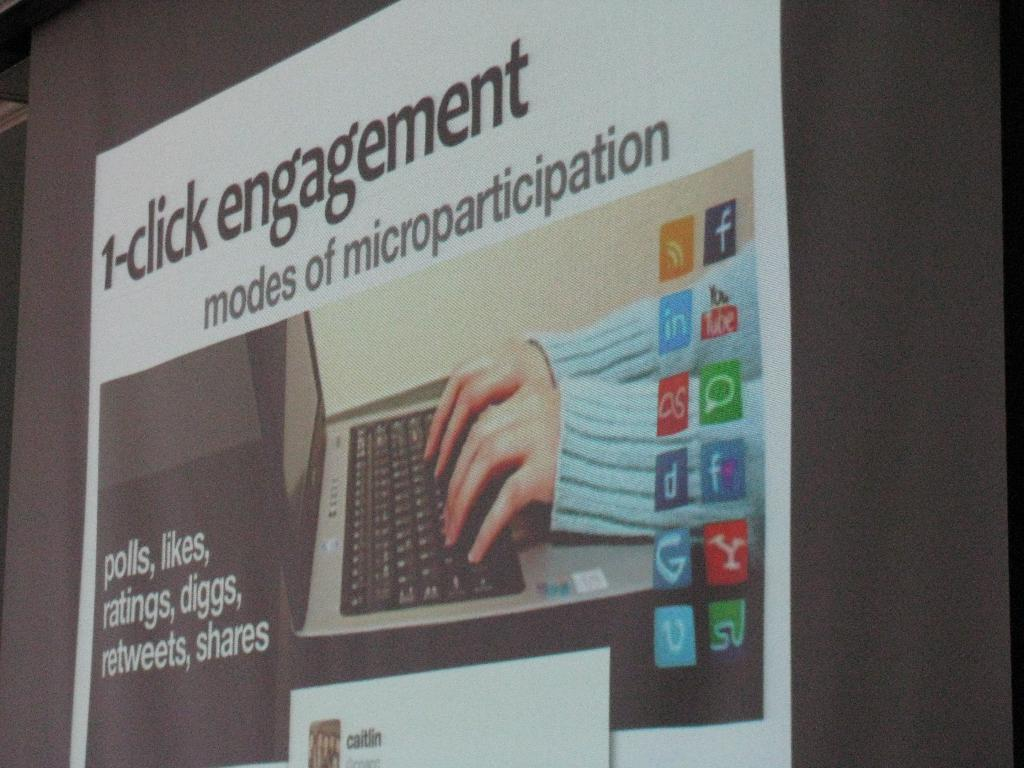<image>
Describe the image concisely. A banner advertises something called "1-click engagement" and features logos for Facebook, YouTube, and other social media platforms. 